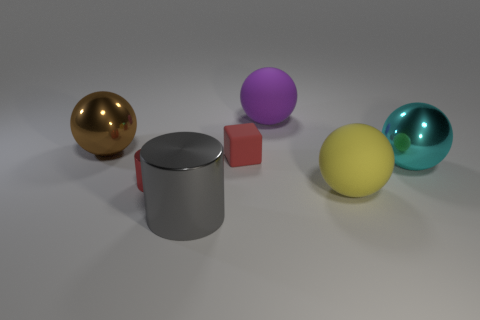Add 2 tiny brown rubber cylinders. How many objects exist? 9 Subtract all purple spheres. How many spheres are left? 3 Subtract all blocks. How many objects are left? 6 Subtract 2 balls. How many balls are left? 2 Subtract all big brown metallic objects. Subtract all brown shiny objects. How many objects are left? 5 Add 3 large cyan balls. How many large cyan balls are left? 4 Add 3 rubber cylinders. How many rubber cylinders exist? 3 Subtract 0 brown cubes. How many objects are left? 7 Subtract all gray cylinders. Subtract all brown blocks. How many cylinders are left? 1 